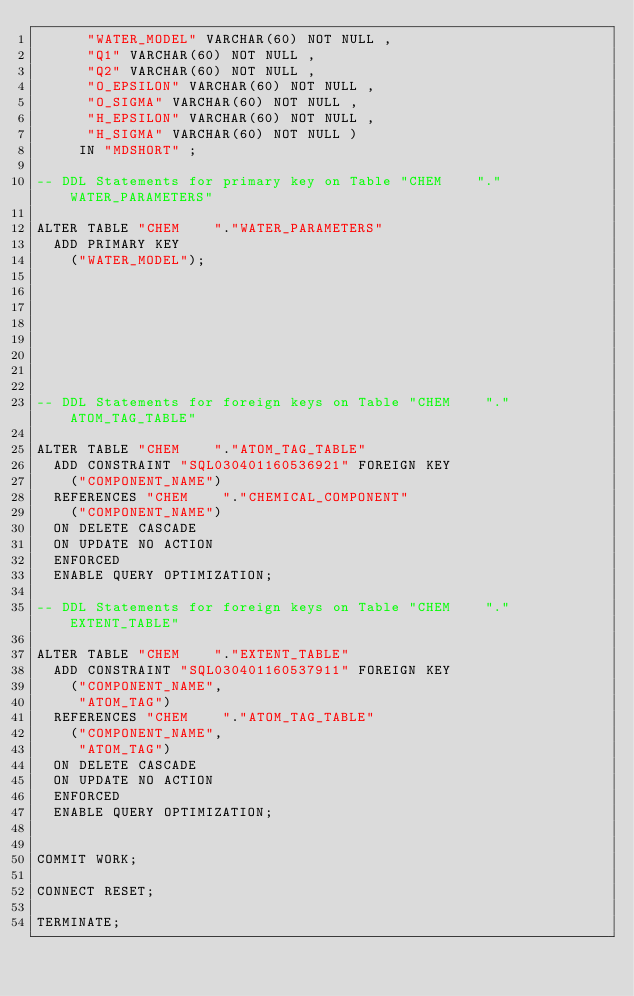<code> <loc_0><loc_0><loc_500><loc_500><_SQL_>		  "WATER_MODEL" VARCHAR(60) NOT NULL , 
		  "Q1" VARCHAR(60) NOT NULL , 
		  "Q2" VARCHAR(60) NOT NULL , 
		  "O_EPSILON" VARCHAR(60) NOT NULL , 
		  "O_SIGMA" VARCHAR(60) NOT NULL , 
		  "H_EPSILON" VARCHAR(60) NOT NULL , 
		  "H_SIGMA" VARCHAR(60) NOT NULL )   
		 IN "MDSHORT" ; 

-- DDL Statements for primary key on Table "CHEM    "."WATER_PARAMETERS"

ALTER TABLE "CHEM    "."WATER_PARAMETERS" 
	ADD PRIMARY KEY
		("WATER_MODEL");








-- DDL Statements for foreign keys on Table "CHEM    "."ATOM_TAG_TABLE"

ALTER TABLE "CHEM    "."ATOM_TAG_TABLE" 
	ADD CONSTRAINT "SQL030401160536921" FOREIGN KEY
		("COMPONENT_NAME")
	REFERENCES "CHEM    "."CHEMICAL_COMPONENT"
		("COMPONENT_NAME")
	ON DELETE CASCADE
	ON UPDATE NO ACTION
	ENFORCED
	ENABLE QUERY OPTIMIZATION;

-- DDL Statements for foreign keys on Table "CHEM    "."EXTENT_TABLE"

ALTER TABLE "CHEM    "."EXTENT_TABLE" 
	ADD CONSTRAINT "SQL030401160537911" FOREIGN KEY
		("COMPONENT_NAME",
		 "ATOM_TAG")
	REFERENCES "CHEM    "."ATOM_TAG_TABLE"
		("COMPONENT_NAME",
		 "ATOM_TAG")
	ON DELETE CASCADE
	ON UPDATE NO ACTION
	ENFORCED
	ENABLE QUERY OPTIMIZATION;


COMMIT WORK;

CONNECT RESET;

TERMINATE;
</code> 